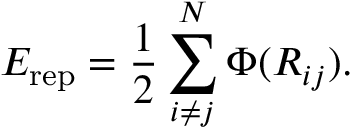<formula> <loc_0><loc_0><loc_500><loc_500>E _ { r e p } = \frac { 1 } { 2 } \sum _ { i \neq j } ^ { N } \Phi ( R _ { i j } ) .</formula> 